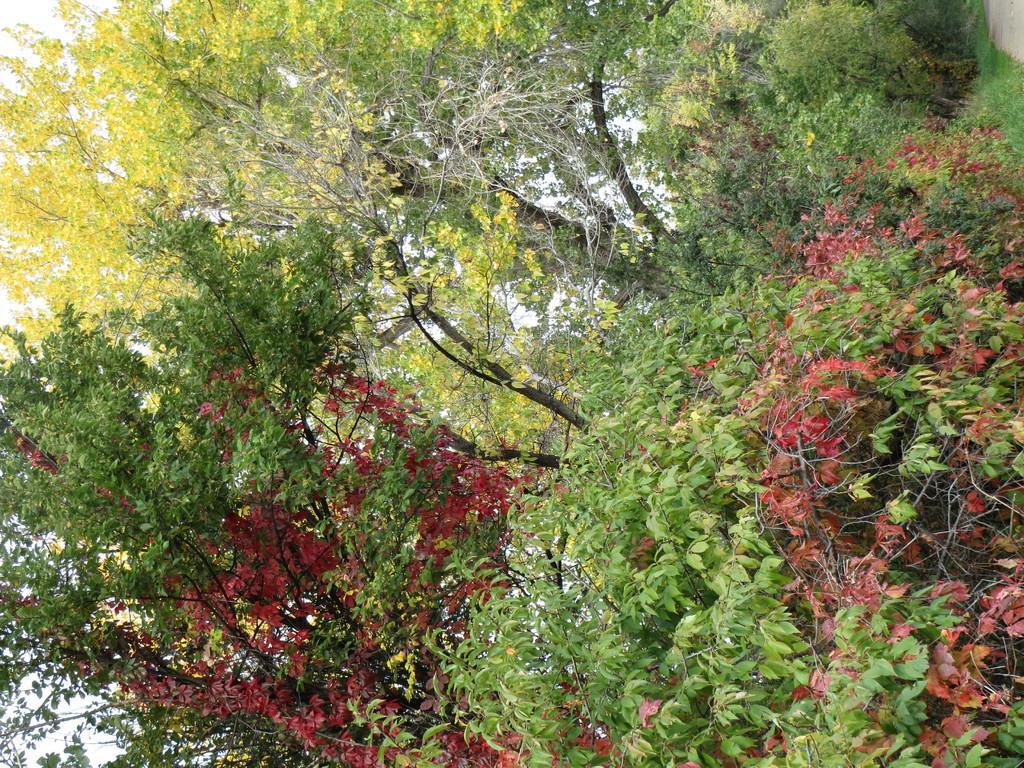In one or two sentences, can you explain what this image depicts? In this image we can see many trees and leaves of the trees are in different colors. There is a sky in the image. 